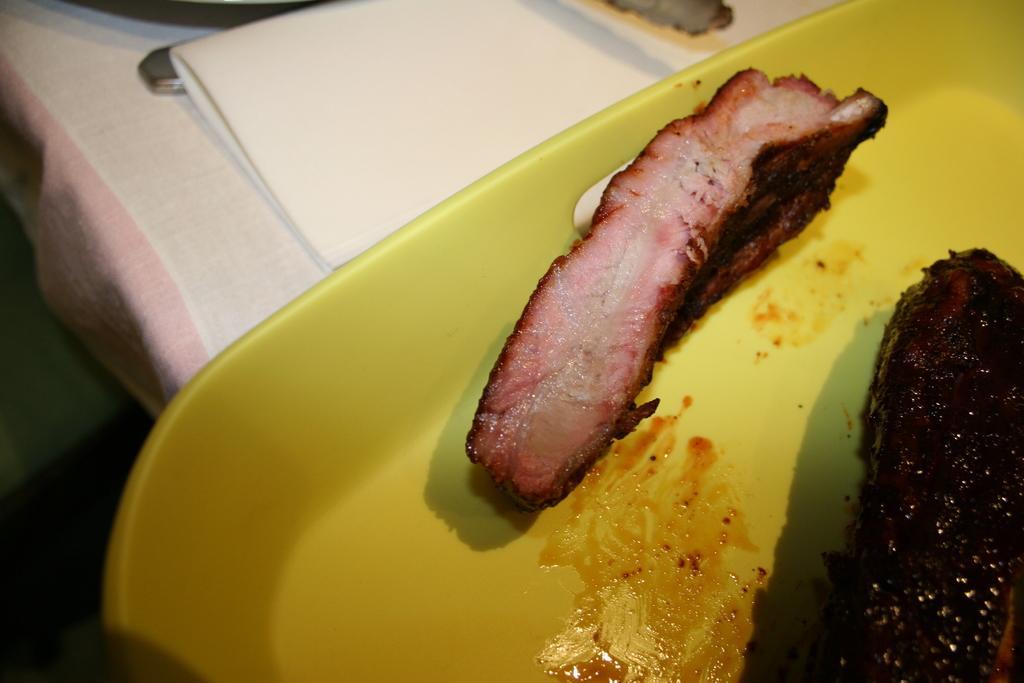Could you give a brief overview of what you see in this image? In this image I can see the food in brown color and the food is in the yellow color plate and background I can see some object in white color. 